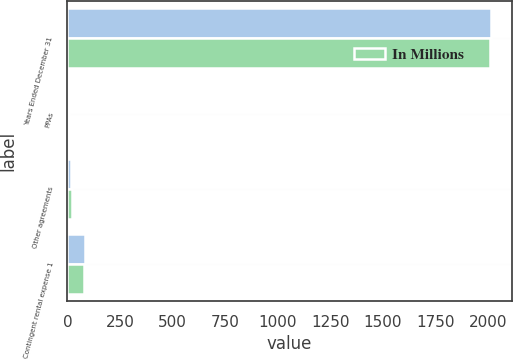Convert chart. <chart><loc_0><loc_0><loc_500><loc_500><stacked_bar_chart><ecel><fcel>Years Ended December 31<fcel>PPAs<fcel>Other agreements<fcel>Contingent rental expense 1<nl><fcel>nan<fcel>2014<fcel>6<fcel>19<fcel>85<nl><fcel>In Millions<fcel>2013<fcel>6<fcel>21<fcel>77<nl></chart> 